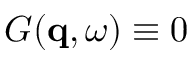Convert formula to latex. <formula><loc_0><loc_0><loc_500><loc_500>G ( q , \omega ) \equiv 0</formula> 